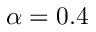Convert formula to latex. <formula><loc_0><loc_0><loc_500><loc_500>\alpha = 0 . 4</formula> 